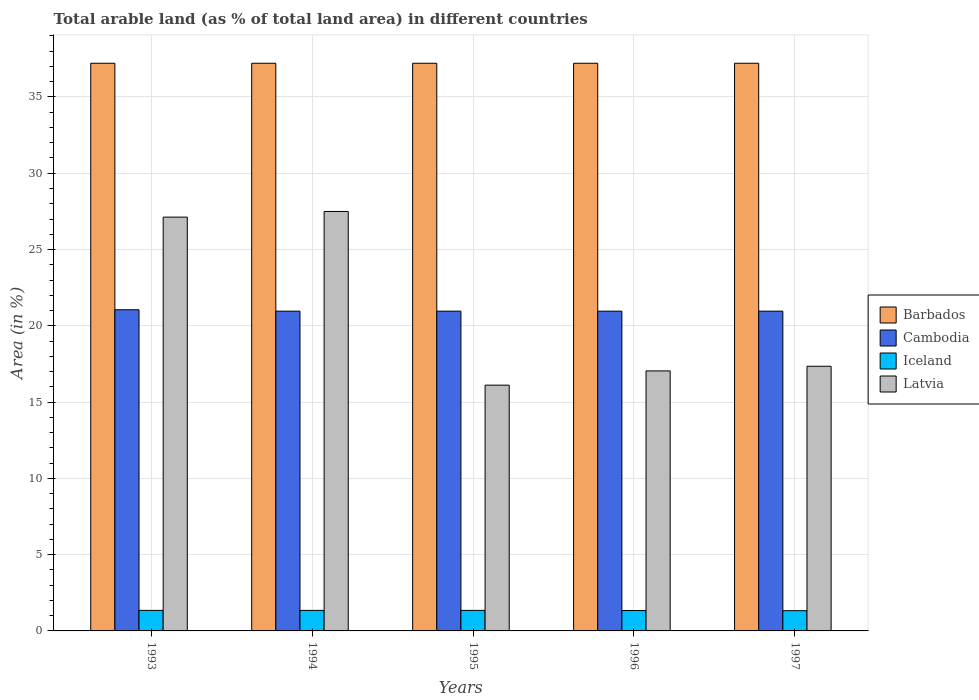How many different coloured bars are there?
Give a very brief answer. 4. How many bars are there on the 5th tick from the right?
Offer a terse response. 4. What is the label of the 4th group of bars from the left?
Offer a terse response. 1996. In how many cases, is the number of bars for a given year not equal to the number of legend labels?
Offer a very short reply. 0. What is the percentage of arable land in Latvia in 1993?
Offer a very short reply. 27.12. Across all years, what is the maximum percentage of arable land in Barbados?
Provide a succinct answer. 37.21. Across all years, what is the minimum percentage of arable land in Cambodia?
Keep it short and to the point. 20.96. What is the total percentage of arable land in Latvia in the graph?
Offer a terse response. 105.12. What is the difference between the percentage of arable land in Cambodia in 1993 and that in 1997?
Provide a short and direct response. 0.09. What is the difference between the percentage of arable land in Iceland in 1993 and the percentage of arable land in Cambodia in 1995?
Offer a very short reply. -19.61. What is the average percentage of arable land in Latvia per year?
Keep it short and to the point. 21.02. In the year 1996, what is the difference between the percentage of arable land in Latvia and percentage of arable land in Cambodia?
Your answer should be compact. -3.92. What is the ratio of the percentage of arable land in Latvia in 1993 to that in 1997?
Your response must be concise. 1.56. Is the percentage of arable land in Barbados in 1993 less than that in 1997?
Offer a terse response. No. What is the difference between the highest and the second highest percentage of arable land in Barbados?
Keep it short and to the point. 0. What is the difference between the highest and the lowest percentage of arable land in Latvia?
Ensure brevity in your answer.  11.38. In how many years, is the percentage of arable land in Latvia greater than the average percentage of arable land in Latvia taken over all years?
Give a very brief answer. 2. Is it the case that in every year, the sum of the percentage of arable land in Barbados and percentage of arable land in Latvia is greater than the sum of percentage of arable land in Iceland and percentage of arable land in Cambodia?
Keep it short and to the point. Yes. What does the 2nd bar from the left in 1994 represents?
Keep it short and to the point. Cambodia. What does the 4th bar from the right in 1996 represents?
Give a very brief answer. Barbados. How many bars are there?
Give a very brief answer. 20. How many years are there in the graph?
Your answer should be very brief. 5. What is the difference between two consecutive major ticks on the Y-axis?
Offer a very short reply. 5. Does the graph contain any zero values?
Make the answer very short. No. How many legend labels are there?
Provide a short and direct response. 4. How are the legend labels stacked?
Your answer should be compact. Vertical. What is the title of the graph?
Provide a short and direct response. Total arable land (as % of total land area) in different countries. Does "United States" appear as one of the legend labels in the graph?
Offer a terse response. No. What is the label or title of the Y-axis?
Your response must be concise. Area (in %). What is the Area (in %) in Barbados in 1993?
Offer a very short reply. 37.21. What is the Area (in %) of Cambodia in 1993?
Make the answer very short. 21.05. What is the Area (in %) of Iceland in 1993?
Your response must be concise. 1.35. What is the Area (in %) in Latvia in 1993?
Keep it short and to the point. 27.12. What is the Area (in %) of Barbados in 1994?
Offer a terse response. 37.21. What is the Area (in %) in Cambodia in 1994?
Your answer should be very brief. 20.96. What is the Area (in %) of Iceland in 1994?
Make the answer very short. 1.35. What is the Area (in %) of Latvia in 1994?
Provide a short and direct response. 27.49. What is the Area (in %) in Barbados in 1995?
Offer a very short reply. 37.21. What is the Area (in %) of Cambodia in 1995?
Give a very brief answer. 20.96. What is the Area (in %) of Iceland in 1995?
Give a very brief answer. 1.35. What is the Area (in %) of Latvia in 1995?
Give a very brief answer. 16.11. What is the Area (in %) of Barbados in 1996?
Your response must be concise. 37.21. What is the Area (in %) of Cambodia in 1996?
Make the answer very short. 20.96. What is the Area (in %) in Iceland in 1996?
Your answer should be very brief. 1.34. What is the Area (in %) of Latvia in 1996?
Keep it short and to the point. 17.04. What is the Area (in %) of Barbados in 1997?
Make the answer very short. 37.21. What is the Area (in %) of Cambodia in 1997?
Your answer should be very brief. 20.96. What is the Area (in %) in Iceland in 1997?
Give a very brief answer. 1.33. What is the Area (in %) in Latvia in 1997?
Your answer should be compact. 17.35. Across all years, what is the maximum Area (in %) of Barbados?
Make the answer very short. 37.21. Across all years, what is the maximum Area (in %) of Cambodia?
Provide a short and direct response. 21.05. Across all years, what is the maximum Area (in %) in Iceland?
Provide a short and direct response. 1.35. Across all years, what is the maximum Area (in %) of Latvia?
Provide a short and direct response. 27.49. Across all years, what is the minimum Area (in %) of Barbados?
Your answer should be compact. 37.21. Across all years, what is the minimum Area (in %) of Cambodia?
Provide a succinct answer. 20.96. Across all years, what is the minimum Area (in %) of Iceland?
Ensure brevity in your answer.  1.33. Across all years, what is the minimum Area (in %) of Latvia?
Offer a terse response. 16.11. What is the total Area (in %) of Barbados in the graph?
Offer a very short reply. 186.05. What is the total Area (in %) of Cambodia in the graph?
Ensure brevity in your answer.  104.89. What is the total Area (in %) of Iceland in the graph?
Make the answer very short. 6.7. What is the total Area (in %) of Latvia in the graph?
Ensure brevity in your answer.  105.12. What is the difference between the Area (in %) in Barbados in 1993 and that in 1994?
Offer a very short reply. 0. What is the difference between the Area (in %) of Cambodia in 1993 and that in 1994?
Your answer should be very brief. 0.09. What is the difference between the Area (in %) of Iceland in 1993 and that in 1994?
Provide a short and direct response. 0. What is the difference between the Area (in %) of Latvia in 1993 and that in 1994?
Give a very brief answer. -0.37. What is the difference between the Area (in %) in Cambodia in 1993 and that in 1995?
Keep it short and to the point. 0.09. What is the difference between the Area (in %) of Latvia in 1993 and that in 1995?
Ensure brevity in your answer.  11.01. What is the difference between the Area (in %) of Cambodia in 1993 and that in 1996?
Offer a terse response. 0.09. What is the difference between the Area (in %) in Latvia in 1993 and that in 1996?
Offer a very short reply. 10.08. What is the difference between the Area (in %) of Cambodia in 1993 and that in 1997?
Offer a terse response. 0.09. What is the difference between the Area (in %) of Iceland in 1993 and that in 1997?
Offer a very short reply. 0.02. What is the difference between the Area (in %) of Latvia in 1993 and that in 1997?
Provide a succinct answer. 9.78. What is the difference between the Area (in %) in Cambodia in 1994 and that in 1995?
Offer a terse response. 0. What is the difference between the Area (in %) of Latvia in 1994 and that in 1995?
Give a very brief answer. 11.38. What is the difference between the Area (in %) in Cambodia in 1994 and that in 1996?
Your answer should be compact. 0. What is the difference between the Area (in %) in Iceland in 1994 and that in 1996?
Offer a very short reply. 0.01. What is the difference between the Area (in %) in Latvia in 1994 and that in 1996?
Provide a short and direct response. 10.45. What is the difference between the Area (in %) of Cambodia in 1994 and that in 1997?
Make the answer very short. 0. What is the difference between the Area (in %) of Latvia in 1994 and that in 1997?
Your response must be concise. 10.15. What is the difference between the Area (in %) of Cambodia in 1995 and that in 1996?
Your answer should be compact. 0. What is the difference between the Area (in %) in Iceland in 1995 and that in 1996?
Your response must be concise. 0.01. What is the difference between the Area (in %) of Latvia in 1995 and that in 1996?
Your answer should be very brief. -0.93. What is the difference between the Area (in %) in Barbados in 1995 and that in 1997?
Keep it short and to the point. 0. What is the difference between the Area (in %) in Latvia in 1995 and that in 1997?
Your answer should be very brief. -1.24. What is the difference between the Area (in %) of Latvia in 1996 and that in 1997?
Provide a succinct answer. -0.31. What is the difference between the Area (in %) of Barbados in 1993 and the Area (in %) of Cambodia in 1994?
Your answer should be very brief. 16.25. What is the difference between the Area (in %) of Barbados in 1993 and the Area (in %) of Iceland in 1994?
Keep it short and to the point. 35.86. What is the difference between the Area (in %) of Barbados in 1993 and the Area (in %) of Latvia in 1994?
Offer a terse response. 9.72. What is the difference between the Area (in %) in Cambodia in 1993 and the Area (in %) in Iceland in 1994?
Make the answer very short. 19.7. What is the difference between the Area (in %) in Cambodia in 1993 and the Area (in %) in Latvia in 1994?
Your response must be concise. -6.44. What is the difference between the Area (in %) of Iceland in 1993 and the Area (in %) of Latvia in 1994?
Give a very brief answer. -26.15. What is the difference between the Area (in %) of Barbados in 1993 and the Area (in %) of Cambodia in 1995?
Your answer should be very brief. 16.25. What is the difference between the Area (in %) of Barbados in 1993 and the Area (in %) of Iceland in 1995?
Keep it short and to the point. 35.86. What is the difference between the Area (in %) of Barbados in 1993 and the Area (in %) of Latvia in 1995?
Offer a terse response. 21.1. What is the difference between the Area (in %) in Cambodia in 1993 and the Area (in %) in Iceland in 1995?
Give a very brief answer. 19.7. What is the difference between the Area (in %) of Cambodia in 1993 and the Area (in %) of Latvia in 1995?
Keep it short and to the point. 4.94. What is the difference between the Area (in %) in Iceland in 1993 and the Area (in %) in Latvia in 1995?
Keep it short and to the point. -14.76. What is the difference between the Area (in %) in Barbados in 1993 and the Area (in %) in Cambodia in 1996?
Provide a short and direct response. 16.25. What is the difference between the Area (in %) in Barbados in 1993 and the Area (in %) in Iceland in 1996?
Keep it short and to the point. 35.87. What is the difference between the Area (in %) in Barbados in 1993 and the Area (in %) in Latvia in 1996?
Your answer should be very brief. 20.17. What is the difference between the Area (in %) in Cambodia in 1993 and the Area (in %) in Iceland in 1996?
Give a very brief answer. 19.71. What is the difference between the Area (in %) of Cambodia in 1993 and the Area (in %) of Latvia in 1996?
Give a very brief answer. 4.01. What is the difference between the Area (in %) in Iceland in 1993 and the Area (in %) in Latvia in 1996?
Your answer should be compact. -15.7. What is the difference between the Area (in %) in Barbados in 1993 and the Area (in %) in Cambodia in 1997?
Offer a very short reply. 16.25. What is the difference between the Area (in %) of Barbados in 1993 and the Area (in %) of Iceland in 1997?
Keep it short and to the point. 35.88. What is the difference between the Area (in %) of Barbados in 1993 and the Area (in %) of Latvia in 1997?
Your answer should be compact. 19.86. What is the difference between the Area (in %) of Cambodia in 1993 and the Area (in %) of Iceland in 1997?
Your answer should be compact. 19.72. What is the difference between the Area (in %) of Cambodia in 1993 and the Area (in %) of Latvia in 1997?
Your answer should be compact. 3.7. What is the difference between the Area (in %) in Iceland in 1993 and the Area (in %) in Latvia in 1997?
Provide a succinct answer. -16. What is the difference between the Area (in %) of Barbados in 1994 and the Area (in %) of Cambodia in 1995?
Your answer should be very brief. 16.25. What is the difference between the Area (in %) of Barbados in 1994 and the Area (in %) of Iceland in 1995?
Provide a succinct answer. 35.86. What is the difference between the Area (in %) of Barbados in 1994 and the Area (in %) of Latvia in 1995?
Your response must be concise. 21.1. What is the difference between the Area (in %) of Cambodia in 1994 and the Area (in %) of Iceland in 1995?
Your answer should be compact. 19.61. What is the difference between the Area (in %) in Cambodia in 1994 and the Area (in %) in Latvia in 1995?
Your answer should be compact. 4.85. What is the difference between the Area (in %) in Iceland in 1994 and the Area (in %) in Latvia in 1995?
Your answer should be compact. -14.76. What is the difference between the Area (in %) in Barbados in 1994 and the Area (in %) in Cambodia in 1996?
Provide a succinct answer. 16.25. What is the difference between the Area (in %) in Barbados in 1994 and the Area (in %) in Iceland in 1996?
Ensure brevity in your answer.  35.87. What is the difference between the Area (in %) of Barbados in 1994 and the Area (in %) of Latvia in 1996?
Your answer should be compact. 20.17. What is the difference between the Area (in %) of Cambodia in 1994 and the Area (in %) of Iceland in 1996?
Offer a very short reply. 19.62. What is the difference between the Area (in %) of Cambodia in 1994 and the Area (in %) of Latvia in 1996?
Give a very brief answer. 3.92. What is the difference between the Area (in %) in Iceland in 1994 and the Area (in %) in Latvia in 1996?
Offer a terse response. -15.7. What is the difference between the Area (in %) in Barbados in 1994 and the Area (in %) in Cambodia in 1997?
Provide a succinct answer. 16.25. What is the difference between the Area (in %) of Barbados in 1994 and the Area (in %) of Iceland in 1997?
Give a very brief answer. 35.88. What is the difference between the Area (in %) of Barbados in 1994 and the Area (in %) of Latvia in 1997?
Provide a succinct answer. 19.86. What is the difference between the Area (in %) of Cambodia in 1994 and the Area (in %) of Iceland in 1997?
Your answer should be compact. 19.63. What is the difference between the Area (in %) in Cambodia in 1994 and the Area (in %) in Latvia in 1997?
Ensure brevity in your answer.  3.61. What is the difference between the Area (in %) in Iceland in 1994 and the Area (in %) in Latvia in 1997?
Ensure brevity in your answer.  -16. What is the difference between the Area (in %) in Barbados in 1995 and the Area (in %) in Cambodia in 1996?
Provide a short and direct response. 16.25. What is the difference between the Area (in %) of Barbados in 1995 and the Area (in %) of Iceland in 1996?
Ensure brevity in your answer.  35.87. What is the difference between the Area (in %) in Barbados in 1995 and the Area (in %) in Latvia in 1996?
Your answer should be very brief. 20.17. What is the difference between the Area (in %) of Cambodia in 1995 and the Area (in %) of Iceland in 1996?
Provide a short and direct response. 19.62. What is the difference between the Area (in %) in Cambodia in 1995 and the Area (in %) in Latvia in 1996?
Your answer should be very brief. 3.92. What is the difference between the Area (in %) in Iceland in 1995 and the Area (in %) in Latvia in 1996?
Keep it short and to the point. -15.7. What is the difference between the Area (in %) of Barbados in 1995 and the Area (in %) of Cambodia in 1997?
Offer a very short reply. 16.25. What is the difference between the Area (in %) in Barbados in 1995 and the Area (in %) in Iceland in 1997?
Make the answer very short. 35.88. What is the difference between the Area (in %) of Barbados in 1995 and the Area (in %) of Latvia in 1997?
Your answer should be compact. 19.86. What is the difference between the Area (in %) of Cambodia in 1995 and the Area (in %) of Iceland in 1997?
Your answer should be very brief. 19.63. What is the difference between the Area (in %) of Cambodia in 1995 and the Area (in %) of Latvia in 1997?
Offer a very short reply. 3.61. What is the difference between the Area (in %) of Iceland in 1995 and the Area (in %) of Latvia in 1997?
Your answer should be very brief. -16. What is the difference between the Area (in %) in Barbados in 1996 and the Area (in %) in Cambodia in 1997?
Your response must be concise. 16.25. What is the difference between the Area (in %) of Barbados in 1996 and the Area (in %) of Iceland in 1997?
Make the answer very short. 35.88. What is the difference between the Area (in %) in Barbados in 1996 and the Area (in %) in Latvia in 1997?
Ensure brevity in your answer.  19.86. What is the difference between the Area (in %) in Cambodia in 1996 and the Area (in %) in Iceland in 1997?
Offer a very short reply. 19.63. What is the difference between the Area (in %) in Cambodia in 1996 and the Area (in %) in Latvia in 1997?
Offer a very short reply. 3.61. What is the difference between the Area (in %) of Iceland in 1996 and the Area (in %) of Latvia in 1997?
Ensure brevity in your answer.  -16.01. What is the average Area (in %) of Barbados per year?
Offer a terse response. 37.21. What is the average Area (in %) in Cambodia per year?
Your answer should be very brief. 20.98. What is the average Area (in %) of Iceland per year?
Your answer should be very brief. 1.34. What is the average Area (in %) of Latvia per year?
Provide a succinct answer. 21.02. In the year 1993, what is the difference between the Area (in %) of Barbados and Area (in %) of Cambodia?
Offer a very short reply. 16.16. In the year 1993, what is the difference between the Area (in %) of Barbados and Area (in %) of Iceland?
Keep it short and to the point. 35.86. In the year 1993, what is the difference between the Area (in %) of Barbados and Area (in %) of Latvia?
Provide a succinct answer. 10.09. In the year 1993, what is the difference between the Area (in %) in Cambodia and Area (in %) in Iceland?
Provide a short and direct response. 19.7. In the year 1993, what is the difference between the Area (in %) in Cambodia and Area (in %) in Latvia?
Offer a terse response. -6.07. In the year 1993, what is the difference between the Area (in %) of Iceland and Area (in %) of Latvia?
Your response must be concise. -25.78. In the year 1994, what is the difference between the Area (in %) of Barbados and Area (in %) of Cambodia?
Your response must be concise. 16.25. In the year 1994, what is the difference between the Area (in %) of Barbados and Area (in %) of Iceland?
Your answer should be very brief. 35.86. In the year 1994, what is the difference between the Area (in %) of Barbados and Area (in %) of Latvia?
Give a very brief answer. 9.72. In the year 1994, what is the difference between the Area (in %) in Cambodia and Area (in %) in Iceland?
Your answer should be compact. 19.61. In the year 1994, what is the difference between the Area (in %) of Cambodia and Area (in %) of Latvia?
Give a very brief answer. -6.53. In the year 1994, what is the difference between the Area (in %) in Iceland and Area (in %) in Latvia?
Provide a short and direct response. -26.15. In the year 1995, what is the difference between the Area (in %) in Barbados and Area (in %) in Cambodia?
Keep it short and to the point. 16.25. In the year 1995, what is the difference between the Area (in %) in Barbados and Area (in %) in Iceland?
Provide a succinct answer. 35.86. In the year 1995, what is the difference between the Area (in %) in Barbados and Area (in %) in Latvia?
Provide a short and direct response. 21.1. In the year 1995, what is the difference between the Area (in %) in Cambodia and Area (in %) in Iceland?
Offer a very short reply. 19.61. In the year 1995, what is the difference between the Area (in %) of Cambodia and Area (in %) of Latvia?
Ensure brevity in your answer.  4.85. In the year 1995, what is the difference between the Area (in %) of Iceland and Area (in %) of Latvia?
Offer a very short reply. -14.76. In the year 1996, what is the difference between the Area (in %) in Barbados and Area (in %) in Cambodia?
Your answer should be very brief. 16.25. In the year 1996, what is the difference between the Area (in %) of Barbados and Area (in %) of Iceland?
Provide a succinct answer. 35.87. In the year 1996, what is the difference between the Area (in %) of Barbados and Area (in %) of Latvia?
Your answer should be very brief. 20.17. In the year 1996, what is the difference between the Area (in %) of Cambodia and Area (in %) of Iceland?
Offer a terse response. 19.62. In the year 1996, what is the difference between the Area (in %) of Cambodia and Area (in %) of Latvia?
Give a very brief answer. 3.92. In the year 1996, what is the difference between the Area (in %) of Iceland and Area (in %) of Latvia?
Ensure brevity in your answer.  -15.71. In the year 1997, what is the difference between the Area (in %) in Barbados and Area (in %) in Cambodia?
Make the answer very short. 16.25. In the year 1997, what is the difference between the Area (in %) in Barbados and Area (in %) in Iceland?
Your answer should be very brief. 35.88. In the year 1997, what is the difference between the Area (in %) in Barbados and Area (in %) in Latvia?
Ensure brevity in your answer.  19.86. In the year 1997, what is the difference between the Area (in %) in Cambodia and Area (in %) in Iceland?
Provide a succinct answer. 19.63. In the year 1997, what is the difference between the Area (in %) in Cambodia and Area (in %) in Latvia?
Ensure brevity in your answer.  3.61. In the year 1997, what is the difference between the Area (in %) of Iceland and Area (in %) of Latvia?
Your answer should be very brief. -16.02. What is the ratio of the Area (in %) of Barbados in 1993 to that in 1994?
Your response must be concise. 1. What is the ratio of the Area (in %) in Latvia in 1993 to that in 1994?
Your answer should be very brief. 0.99. What is the ratio of the Area (in %) of Cambodia in 1993 to that in 1995?
Provide a short and direct response. 1. What is the ratio of the Area (in %) of Latvia in 1993 to that in 1995?
Provide a succinct answer. 1.68. What is the ratio of the Area (in %) in Cambodia in 1993 to that in 1996?
Keep it short and to the point. 1. What is the ratio of the Area (in %) in Iceland in 1993 to that in 1996?
Your response must be concise. 1.01. What is the ratio of the Area (in %) in Latvia in 1993 to that in 1996?
Your response must be concise. 1.59. What is the ratio of the Area (in %) in Barbados in 1993 to that in 1997?
Provide a short and direct response. 1. What is the ratio of the Area (in %) of Cambodia in 1993 to that in 1997?
Offer a very short reply. 1. What is the ratio of the Area (in %) of Iceland in 1993 to that in 1997?
Make the answer very short. 1.01. What is the ratio of the Area (in %) of Latvia in 1993 to that in 1997?
Keep it short and to the point. 1.56. What is the ratio of the Area (in %) in Latvia in 1994 to that in 1995?
Ensure brevity in your answer.  1.71. What is the ratio of the Area (in %) of Barbados in 1994 to that in 1996?
Offer a very short reply. 1. What is the ratio of the Area (in %) of Cambodia in 1994 to that in 1996?
Make the answer very short. 1. What is the ratio of the Area (in %) in Iceland in 1994 to that in 1996?
Provide a short and direct response. 1.01. What is the ratio of the Area (in %) in Latvia in 1994 to that in 1996?
Provide a short and direct response. 1.61. What is the ratio of the Area (in %) in Barbados in 1994 to that in 1997?
Give a very brief answer. 1. What is the ratio of the Area (in %) of Cambodia in 1994 to that in 1997?
Your response must be concise. 1. What is the ratio of the Area (in %) of Iceland in 1994 to that in 1997?
Your answer should be compact. 1.01. What is the ratio of the Area (in %) of Latvia in 1994 to that in 1997?
Make the answer very short. 1.58. What is the ratio of the Area (in %) in Barbados in 1995 to that in 1996?
Ensure brevity in your answer.  1. What is the ratio of the Area (in %) in Cambodia in 1995 to that in 1996?
Make the answer very short. 1. What is the ratio of the Area (in %) of Iceland in 1995 to that in 1996?
Give a very brief answer. 1.01. What is the ratio of the Area (in %) in Latvia in 1995 to that in 1996?
Provide a succinct answer. 0.95. What is the ratio of the Area (in %) of Barbados in 1995 to that in 1997?
Ensure brevity in your answer.  1. What is the ratio of the Area (in %) in Iceland in 1995 to that in 1997?
Give a very brief answer. 1.01. What is the ratio of the Area (in %) in Latvia in 1995 to that in 1997?
Offer a terse response. 0.93. What is the ratio of the Area (in %) in Iceland in 1996 to that in 1997?
Make the answer very short. 1.01. What is the ratio of the Area (in %) in Latvia in 1996 to that in 1997?
Your answer should be very brief. 0.98. What is the difference between the highest and the second highest Area (in %) of Barbados?
Offer a terse response. 0. What is the difference between the highest and the second highest Area (in %) of Cambodia?
Keep it short and to the point. 0.09. What is the difference between the highest and the second highest Area (in %) of Iceland?
Your response must be concise. 0. What is the difference between the highest and the second highest Area (in %) of Latvia?
Provide a short and direct response. 0.37. What is the difference between the highest and the lowest Area (in %) of Barbados?
Ensure brevity in your answer.  0. What is the difference between the highest and the lowest Area (in %) in Cambodia?
Offer a terse response. 0.09. What is the difference between the highest and the lowest Area (in %) of Iceland?
Provide a succinct answer. 0.02. What is the difference between the highest and the lowest Area (in %) in Latvia?
Keep it short and to the point. 11.38. 